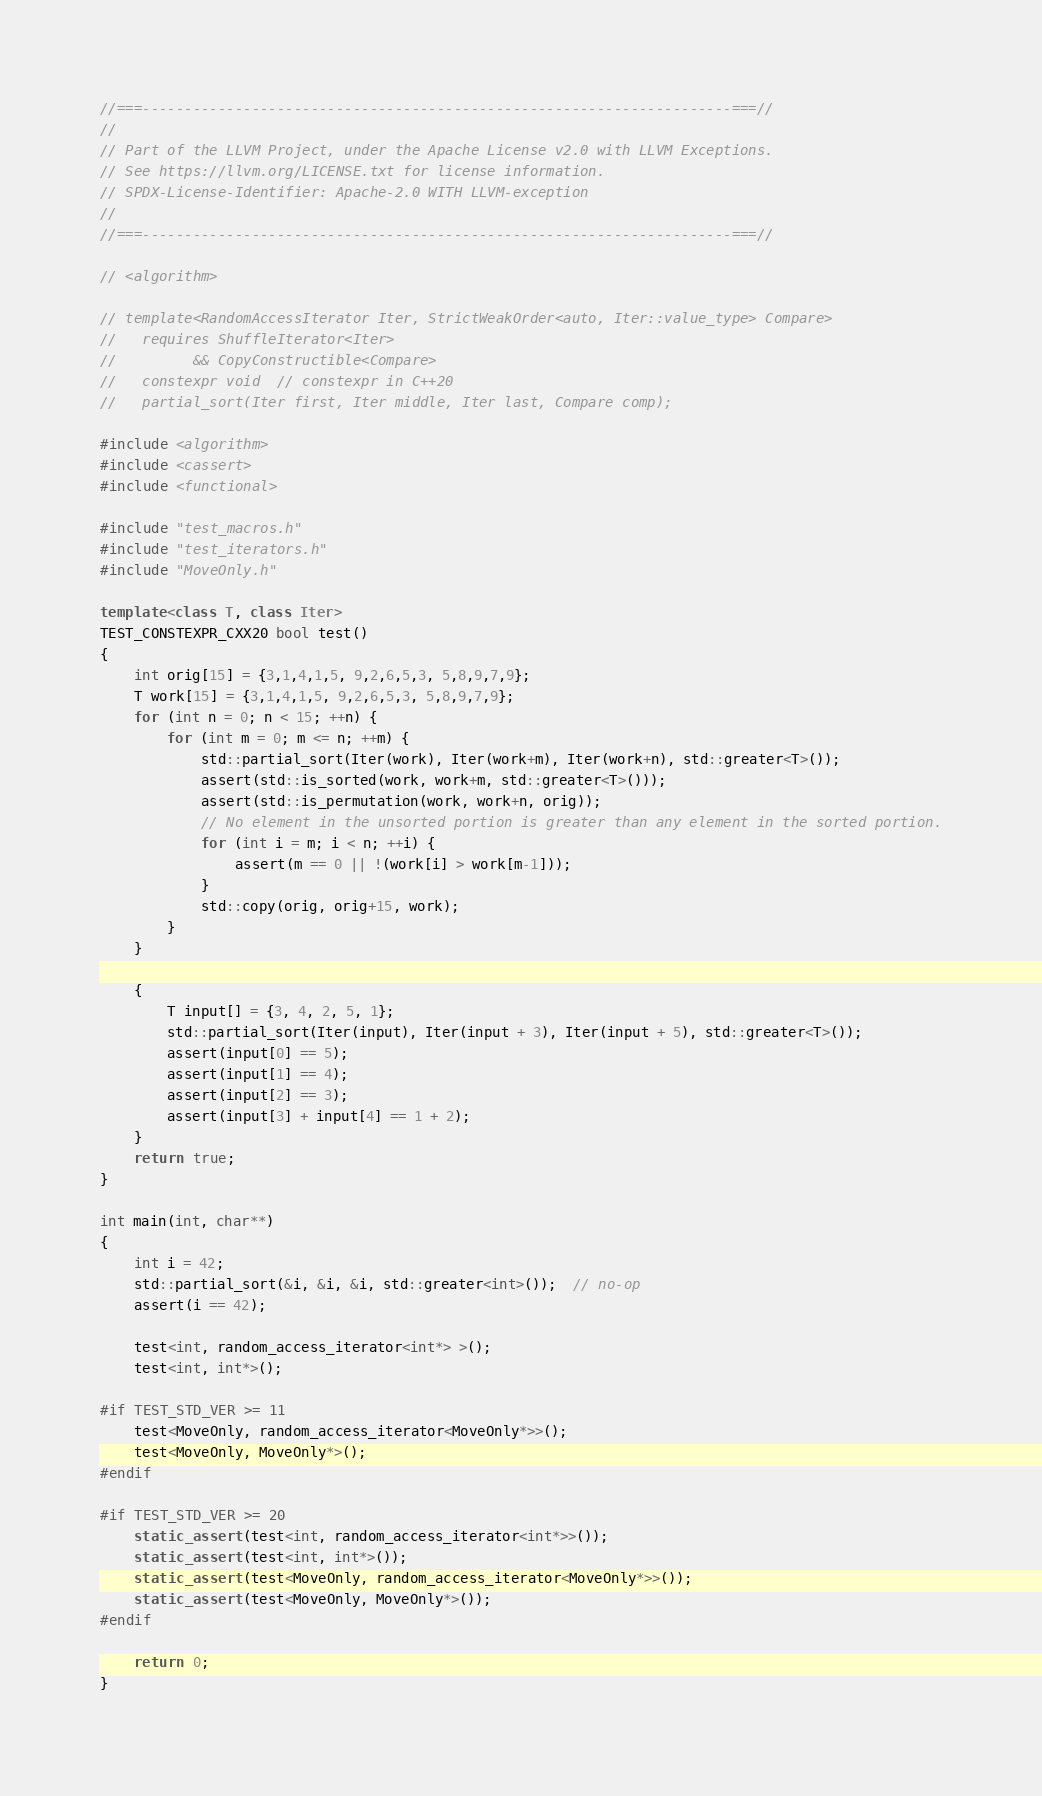<code> <loc_0><loc_0><loc_500><loc_500><_C++_>//===----------------------------------------------------------------------===//
//
// Part of the LLVM Project, under the Apache License v2.0 with LLVM Exceptions.
// See https://llvm.org/LICENSE.txt for license information.
// SPDX-License-Identifier: Apache-2.0 WITH LLVM-exception
//
//===----------------------------------------------------------------------===//

// <algorithm>

// template<RandomAccessIterator Iter, StrictWeakOrder<auto, Iter::value_type> Compare>
//   requires ShuffleIterator<Iter>
//         && CopyConstructible<Compare>
//   constexpr void  // constexpr in C++20
//   partial_sort(Iter first, Iter middle, Iter last, Compare comp);

#include <algorithm>
#include <cassert>
#include <functional>

#include "test_macros.h"
#include "test_iterators.h"
#include "MoveOnly.h"

template<class T, class Iter>
TEST_CONSTEXPR_CXX20 bool test()
{
    int orig[15] = {3,1,4,1,5, 9,2,6,5,3, 5,8,9,7,9};
    T work[15] = {3,1,4,1,5, 9,2,6,5,3, 5,8,9,7,9};
    for (int n = 0; n < 15; ++n) {
        for (int m = 0; m <= n; ++m) {
            std::partial_sort(Iter(work), Iter(work+m), Iter(work+n), std::greater<T>());
            assert(std::is_sorted(work, work+m, std::greater<T>()));
            assert(std::is_permutation(work, work+n, orig));
            // No element in the unsorted portion is greater than any element in the sorted portion.
            for (int i = m; i < n; ++i) {
                assert(m == 0 || !(work[i] > work[m-1]));
            }
            std::copy(orig, orig+15, work);
        }
    }

    {
        T input[] = {3, 4, 2, 5, 1};
        std::partial_sort(Iter(input), Iter(input + 3), Iter(input + 5), std::greater<T>());
        assert(input[0] == 5);
        assert(input[1] == 4);
        assert(input[2] == 3);
        assert(input[3] + input[4] == 1 + 2);
    }
    return true;
}

int main(int, char**)
{
    int i = 42;
    std::partial_sort(&i, &i, &i, std::greater<int>());  // no-op
    assert(i == 42);

    test<int, random_access_iterator<int*> >();
    test<int, int*>();

#if TEST_STD_VER >= 11
    test<MoveOnly, random_access_iterator<MoveOnly*>>();
    test<MoveOnly, MoveOnly*>();
#endif

#if TEST_STD_VER >= 20
    static_assert(test<int, random_access_iterator<int*>>());
    static_assert(test<int, int*>());
    static_assert(test<MoveOnly, random_access_iterator<MoveOnly*>>());
    static_assert(test<MoveOnly, MoveOnly*>());
#endif

    return 0;
}
</code> 